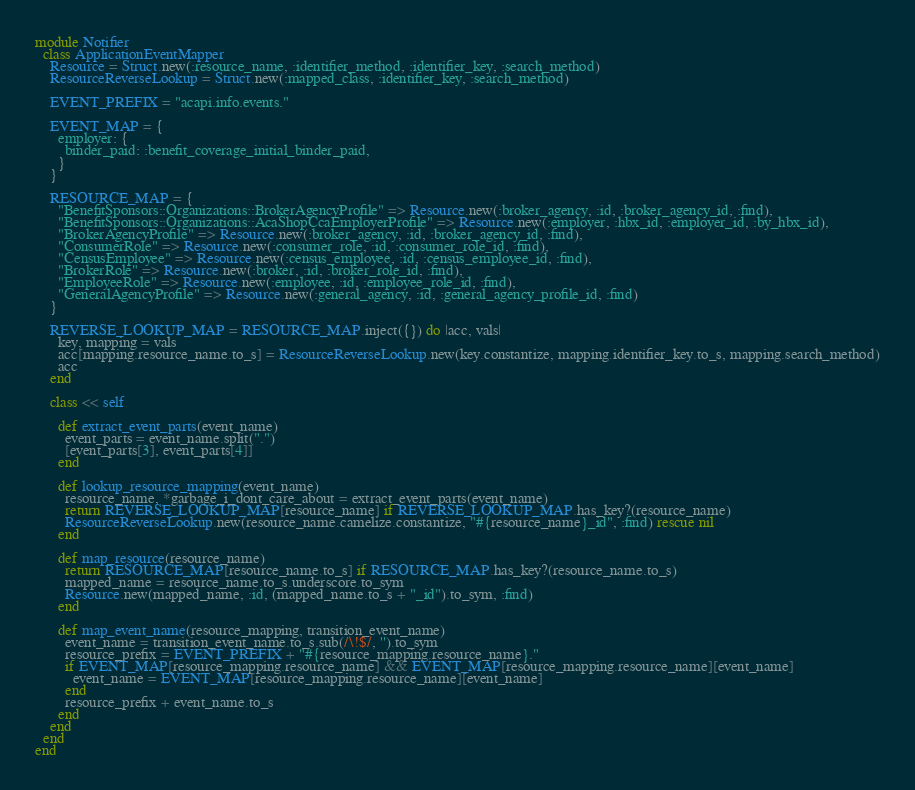<code> <loc_0><loc_0><loc_500><loc_500><_Ruby_>module Notifier
  class ApplicationEventMapper
    Resource = Struct.new(:resource_name, :identifier_method, :identifier_key, :search_method)
    ResourceReverseLookup = Struct.new(:mapped_class, :identifier_key, :search_method)

    EVENT_PREFIX = "acapi.info.events."

    EVENT_MAP = {
      employer: {
        binder_paid: :benefit_coverage_initial_binder_paid,        
      }
    }

    RESOURCE_MAP = {
      "BenefitSponsors::Organizations::BrokerAgencyProfile" => Resource.new(:broker_agency, :id, :broker_agency_id, :find),
      "BenefitSponsors::Organizations::AcaShopCcaEmployerProfile" => Resource.new(:employer, :hbx_id, :employer_id, :by_hbx_id),
      "BrokerAgencyProfile" => Resource.new(:broker_agency, :id, :broker_agency_id, :find),
      "ConsumerRole" => Resource.new(:consumer_role, :id, :consumer_role_id, :find),
      "CensusEmployee" => Resource.new(:census_employee, :id, :census_employee_id, :find),
      "BrokerRole" => Resource.new(:broker, :id, :broker_role_id, :find),
      "EmployeeRole" => Resource.new(:employee, :id, :employee_role_id, :find),
      "GeneralAgencyProfile" => Resource.new(:general_agency, :id, :general_agency_profile_id, :find)
    }

    REVERSE_LOOKUP_MAP = RESOURCE_MAP.inject({}) do |acc, vals|
      key, mapping = vals
      acc[mapping.resource_name.to_s] = ResourceReverseLookup.new(key.constantize, mapping.identifier_key.to_s, mapping.search_method)
      acc
    end

    class << self

      def extract_event_parts(event_name)
        event_parts = event_name.split(".")
        [event_parts[3], event_parts[4]]
      end

      def lookup_resource_mapping(event_name)
        resource_name, *garbage_i_dont_care_about = extract_event_parts(event_name)
        return REVERSE_LOOKUP_MAP[resource_name] if REVERSE_LOOKUP_MAP.has_key?(resource_name)
        ResourceReverseLookup.new(resource_name.camelize.constantize, "#{resource_name}_id", :find) rescue nil
      end

      def map_resource(resource_name)
        return RESOURCE_MAP[resource_name.to_s] if RESOURCE_MAP.has_key?(resource_name.to_s)
        mapped_name = resource_name.to_s.underscore.to_sym
        Resource.new(mapped_name, :id, (mapped_name.to_s + "_id").to_sym, :find)
      end

      def map_event_name(resource_mapping, transition_event_name)
        event_name = transition_event_name.to_s.sub(/\!$/, '').to_sym
        resource_prefix = EVENT_PREFIX + "#{resource_mapping.resource_name}."
        if EVENT_MAP[resource_mapping.resource_name] && EVENT_MAP[resource_mapping.resource_name][event_name]
          event_name = EVENT_MAP[resource_mapping.resource_name][event_name]
        end
        resource_prefix + event_name.to_s
      end
    end
  end
end</code> 